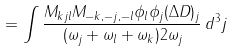Convert formula to latex. <formula><loc_0><loc_0><loc_500><loc_500>= \int \frac { M _ { k j l } M _ { - k , - j , - l } \phi _ { l } \phi _ { j } ( \Delta D ) _ { j } } { ( \omega _ { j } + \omega _ { l } + \omega _ { k } ) 2 \omega _ { j } } \, d ^ { 3 } { j }</formula> 